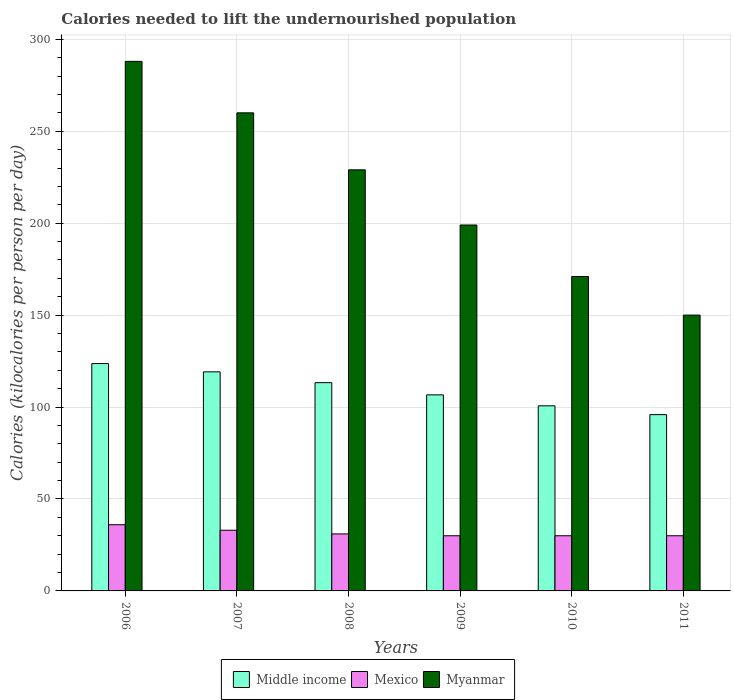How many groups of bars are there?
Keep it short and to the point. 6. Are the number of bars per tick equal to the number of legend labels?
Provide a short and direct response. Yes. Are the number of bars on each tick of the X-axis equal?
Your response must be concise. Yes. How many bars are there on the 6th tick from the left?
Provide a succinct answer. 3. How many bars are there on the 3rd tick from the right?
Your answer should be compact. 3. What is the label of the 5th group of bars from the left?
Give a very brief answer. 2010. In how many cases, is the number of bars for a given year not equal to the number of legend labels?
Keep it short and to the point. 0. What is the total calories needed to lift the undernourished population in Middle income in 2007?
Ensure brevity in your answer.  119.14. Across all years, what is the maximum total calories needed to lift the undernourished population in Middle income?
Your response must be concise. 123.65. Across all years, what is the minimum total calories needed to lift the undernourished population in Middle income?
Your answer should be very brief. 95.87. In which year was the total calories needed to lift the undernourished population in Middle income minimum?
Ensure brevity in your answer.  2011. What is the total total calories needed to lift the undernourished population in Mexico in the graph?
Ensure brevity in your answer.  190. What is the difference between the total calories needed to lift the undernourished population in Myanmar in 2007 and that in 2010?
Provide a succinct answer. 89. What is the difference between the total calories needed to lift the undernourished population in Middle income in 2010 and the total calories needed to lift the undernourished population in Mexico in 2009?
Make the answer very short. 70.68. What is the average total calories needed to lift the undernourished population in Myanmar per year?
Give a very brief answer. 216.17. In the year 2007, what is the difference between the total calories needed to lift the undernourished population in Myanmar and total calories needed to lift the undernourished population in Mexico?
Your response must be concise. 227. In how many years, is the total calories needed to lift the undernourished population in Myanmar greater than 130 kilocalories?
Provide a short and direct response. 6. What is the ratio of the total calories needed to lift the undernourished population in Mexico in 2008 to that in 2011?
Your response must be concise. 1.03. Is the total calories needed to lift the undernourished population in Mexico in 2006 less than that in 2010?
Provide a short and direct response. No. What is the difference between the highest and the second highest total calories needed to lift the undernourished population in Mexico?
Provide a short and direct response. 3. What is the difference between the highest and the lowest total calories needed to lift the undernourished population in Middle income?
Make the answer very short. 27.78. What does the 2nd bar from the right in 2011 represents?
Your answer should be compact. Mexico. How many years are there in the graph?
Give a very brief answer. 6. Are the values on the major ticks of Y-axis written in scientific E-notation?
Keep it short and to the point. No. Does the graph contain any zero values?
Keep it short and to the point. No. How are the legend labels stacked?
Keep it short and to the point. Horizontal. What is the title of the graph?
Ensure brevity in your answer.  Calories needed to lift the undernourished population. What is the label or title of the Y-axis?
Keep it short and to the point. Calories (kilocalories per person per day). What is the Calories (kilocalories per person per day) in Middle income in 2006?
Make the answer very short. 123.65. What is the Calories (kilocalories per person per day) in Mexico in 2006?
Make the answer very short. 36. What is the Calories (kilocalories per person per day) in Myanmar in 2006?
Offer a terse response. 288. What is the Calories (kilocalories per person per day) of Middle income in 2007?
Ensure brevity in your answer.  119.14. What is the Calories (kilocalories per person per day) in Myanmar in 2007?
Make the answer very short. 260. What is the Calories (kilocalories per person per day) of Middle income in 2008?
Offer a terse response. 113.26. What is the Calories (kilocalories per person per day) in Mexico in 2008?
Your answer should be compact. 31. What is the Calories (kilocalories per person per day) in Myanmar in 2008?
Ensure brevity in your answer.  229. What is the Calories (kilocalories per person per day) of Middle income in 2009?
Give a very brief answer. 106.62. What is the Calories (kilocalories per person per day) of Mexico in 2009?
Provide a succinct answer. 30. What is the Calories (kilocalories per person per day) in Myanmar in 2009?
Give a very brief answer. 199. What is the Calories (kilocalories per person per day) of Middle income in 2010?
Keep it short and to the point. 100.68. What is the Calories (kilocalories per person per day) of Myanmar in 2010?
Your answer should be compact. 171. What is the Calories (kilocalories per person per day) of Middle income in 2011?
Your answer should be very brief. 95.87. What is the Calories (kilocalories per person per day) of Mexico in 2011?
Your answer should be very brief. 30. What is the Calories (kilocalories per person per day) in Myanmar in 2011?
Your answer should be very brief. 150. Across all years, what is the maximum Calories (kilocalories per person per day) of Middle income?
Make the answer very short. 123.65. Across all years, what is the maximum Calories (kilocalories per person per day) of Mexico?
Ensure brevity in your answer.  36. Across all years, what is the maximum Calories (kilocalories per person per day) of Myanmar?
Ensure brevity in your answer.  288. Across all years, what is the minimum Calories (kilocalories per person per day) of Middle income?
Ensure brevity in your answer.  95.87. Across all years, what is the minimum Calories (kilocalories per person per day) of Myanmar?
Your response must be concise. 150. What is the total Calories (kilocalories per person per day) in Middle income in the graph?
Give a very brief answer. 659.21. What is the total Calories (kilocalories per person per day) in Mexico in the graph?
Offer a very short reply. 190. What is the total Calories (kilocalories per person per day) of Myanmar in the graph?
Offer a terse response. 1297. What is the difference between the Calories (kilocalories per person per day) of Middle income in 2006 and that in 2007?
Offer a very short reply. 4.51. What is the difference between the Calories (kilocalories per person per day) of Middle income in 2006 and that in 2008?
Give a very brief answer. 10.39. What is the difference between the Calories (kilocalories per person per day) in Middle income in 2006 and that in 2009?
Offer a very short reply. 17.03. What is the difference between the Calories (kilocalories per person per day) of Myanmar in 2006 and that in 2009?
Ensure brevity in your answer.  89. What is the difference between the Calories (kilocalories per person per day) of Middle income in 2006 and that in 2010?
Offer a very short reply. 22.97. What is the difference between the Calories (kilocalories per person per day) of Mexico in 2006 and that in 2010?
Offer a terse response. 6. What is the difference between the Calories (kilocalories per person per day) of Myanmar in 2006 and that in 2010?
Make the answer very short. 117. What is the difference between the Calories (kilocalories per person per day) of Middle income in 2006 and that in 2011?
Your response must be concise. 27.78. What is the difference between the Calories (kilocalories per person per day) in Myanmar in 2006 and that in 2011?
Offer a terse response. 138. What is the difference between the Calories (kilocalories per person per day) in Middle income in 2007 and that in 2008?
Provide a succinct answer. 5.88. What is the difference between the Calories (kilocalories per person per day) of Myanmar in 2007 and that in 2008?
Offer a terse response. 31. What is the difference between the Calories (kilocalories per person per day) of Middle income in 2007 and that in 2009?
Ensure brevity in your answer.  12.51. What is the difference between the Calories (kilocalories per person per day) in Mexico in 2007 and that in 2009?
Your response must be concise. 3. What is the difference between the Calories (kilocalories per person per day) of Middle income in 2007 and that in 2010?
Offer a very short reply. 18.46. What is the difference between the Calories (kilocalories per person per day) of Mexico in 2007 and that in 2010?
Offer a very short reply. 3. What is the difference between the Calories (kilocalories per person per day) in Myanmar in 2007 and that in 2010?
Give a very brief answer. 89. What is the difference between the Calories (kilocalories per person per day) of Middle income in 2007 and that in 2011?
Ensure brevity in your answer.  23.27. What is the difference between the Calories (kilocalories per person per day) of Myanmar in 2007 and that in 2011?
Give a very brief answer. 110. What is the difference between the Calories (kilocalories per person per day) in Middle income in 2008 and that in 2009?
Make the answer very short. 6.63. What is the difference between the Calories (kilocalories per person per day) in Mexico in 2008 and that in 2009?
Give a very brief answer. 1. What is the difference between the Calories (kilocalories per person per day) in Middle income in 2008 and that in 2010?
Offer a very short reply. 12.58. What is the difference between the Calories (kilocalories per person per day) in Mexico in 2008 and that in 2010?
Ensure brevity in your answer.  1. What is the difference between the Calories (kilocalories per person per day) of Middle income in 2008 and that in 2011?
Give a very brief answer. 17.39. What is the difference between the Calories (kilocalories per person per day) in Myanmar in 2008 and that in 2011?
Your response must be concise. 79. What is the difference between the Calories (kilocalories per person per day) of Middle income in 2009 and that in 2010?
Your response must be concise. 5.95. What is the difference between the Calories (kilocalories per person per day) of Mexico in 2009 and that in 2010?
Keep it short and to the point. 0. What is the difference between the Calories (kilocalories per person per day) in Myanmar in 2009 and that in 2010?
Provide a succinct answer. 28. What is the difference between the Calories (kilocalories per person per day) of Middle income in 2009 and that in 2011?
Offer a terse response. 10.76. What is the difference between the Calories (kilocalories per person per day) in Myanmar in 2009 and that in 2011?
Your answer should be very brief. 49. What is the difference between the Calories (kilocalories per person per day) of Middle income in 2010 and that in 2011?
Your response must be concise. 4.81. What is the difference between the Calories (kilocalories per person per day) of Middle income in 2006 and the Calories (kilocalories per person per day) of Mexico in 2007?
Provide a short and direct response. 90.65. What is the difference between the Calories (kilocalories per person per day) of Middle income in 2006 and the Calories (kilocalories per person per day) of Myanmar in 2007?
Your answer should be compact. -136.35. What is the difference between the Calories (kilocalories per person per day) in Mexico in 2006 and the Calories (kilocalories per person per day) in Myanmar in 2007?
Give a very brief answer. -224. What is the difference between the Calories (kilocalories per person per day) in Middle income in 2006 and the Calories (kilocalories per person per day) in Mexico in 2008?
Make the answer very short. 92.65. What is the difference between the Calories (kilocalories per person per day) of Middle income in 2006 and the Calories (kilocalories per person per day) of Myanmar in 2008?
Your response must be concise. -105.35. What is the difference between the Calories (kilocalories per person per day) in Mexico in 2006 and the Calories (kilocalories per person per day) in Myanmar in 2008?
Ensure brevity in your answer.  -193. What is the difference between the Calories (kilocalories per person per day) in Middle income in 2006 and the Calories (kilocalories per person per day) in Mexico in 2009?
Offer a terse response. 93.65. What is the difference between the Calories (kilocalories per person per day) in Middle income in 2006 and the Calories (kilocalories per person per day) in Myanmar in 2009?
Your answer should be compact. -75.35. What is the difference between the Calories (kilocalories per person per day) of Mexico in 2006 and the Calories (kilocalories per person per day) of Myanmar in 2009?
Ensure brevity in your answer.  -163. What is the difference between the Calories (kilocalories per person per day) in Middle income in 2006 and the Calories (kilocalories per person per day) in Mexico in 2010?
Offer a terse response. 93.65. What is the difference between the Calories (kilocalories per person per day) of Middle income in 2006 and the Calories (kilocalories per person per day) of Myanmar in 2010?
Your answer should be very brief. -47.35. What is the difference between the Calories (kilocalories per person per day) in Mexico in 2006 and the Calories (kilocalories per person per day) in Myanmar in 2010?
Provide a succinct answer. -135. What is the difference between the Calories (kilocalories per person per day) in Middle income in 2006 and the Calories (kilocalories per person per day) in Mexico in 2011?
Make the answer very short. 93.65. What is the difference between the Calories (kilocalories per person per day) of Middle income in 2006 and the Calories (kilocalories per person per day) of Myanmar in 2011?
Provide a short and direct response. -26.35. What is the difference between the Calories (kilocalories per person per day) of Mexico in 2006 and the Calories (kilocalories per person per day) of Myanmar in 2011?
Your answer should be very brief. -114. What is the difference between the Calories (kilocalories per person per day) of Middle income in 2007 and the Calories (kilocalories per person per day) of Mexico in 2008?
Keep it short and to the point. 88.14. What is the difference between the Calories (kilocalories per person per day) in Middle income in 2007 and the Calories (kilocalories per person per day) in Myanmar in 2008?
Your answer should be very brief. -109.86. What is the difference between the Calories (kilocalories per person per day) in Mexico in 2007 and the Calories (kilocalories per person per day) in Myanmar in 2008?
Your answer should be compact. -196. What is the difference between the Calories (kilocalories per person per day) in Middle income in 2007 and the Calories (kilocalories per person per day) in Mexico in 2009?
Provide a succinct answer. 89.14. What is the difference between the Calories (kilocalories per person per day) in Middle income in 2007 and the Calories (kilocalories per person per day) in Myanmar in 2009?
Offer a very short reply. -79.86. What is the difference between the Calories (kilocalories per person per day) of Mexico in 2007 and the Calories (kilocalories per person per day) of Myanmar in 2009?
Ensure brevity in your answer.  -166. What is the difference between the Calories (kilocalories per person per day) in Middle income in 2007 and the Calories (kilocalories per person per day) in Mexico in 2010?
Make the answer very short. 89.14. What is the difference between the Calories (kilocalories per person per day) of Middle income in 2007 and the Calories (kilocalories per person per day) of Myanmar in 2010?
Your response must be concise. -51.86. What is the difference between the Calories (kilocalories per person per day) in Mexico in 2007 and the Calories (kilocalories per person per day) in Myanmar in 2010?
Make the answer very short. -138. What is the difference between the Calories (kilocalories per person per day) in Middle income in 2007 and the Calories (kilocalories per person per day) in Mexico in 2011?
Offer a very short reply. 89.14. What is the difference between the Calories (kilocalories per person per day) in Middle income in 2007 and the Calories (kilocalories per person per day) in Myanmar in 2011?
Offer a terse response. -30.86. What is the difference between the Calories (kilocalories per person per day) in Mexico in 2007 and the Calories (kilocalories per person per day) in Myanmar in 2011?
Offer a very short reply. -117. What is the difference between the Calories (kilocalories per person per day) of Middle income in 2008 and the Calories (kilocalories per person per day) of Mexico in 2009?
Your response must be concise. 83.26. What is the difference between the Calories (kilocalories per person per day) of Middle income in 2008 and the Calories (kilocalories per person per day) of Myanmar in 2009?
Ensure brevity in your answer.  -85.74. What is the difference between the Calories (kilocalories per person per day) of Mexico in 2008 and the Calories (kilocalories per person per day) of Myanmar in 2009?
Offer a terse response. -168. What is the difference between the Calories (kilocalories per person per day) in Middle income in 2008 and the Calories (kilocalories per person per day) in Mexico in 2010?
Offer a very short reply. 83.26. What is the difference between the Calories (kilocalories per person per day) of Middle income in 2008 and the Calories (kilocalories per person per day) of Myanmar in 2010?
Your answer should be compact. -57.74. What is the difference between the Calories (kilocalories per person per day) of Mexico in 2008 and the Calories (kilocalories per person per day) of Myanmar in 2010?
Provide a short and direct response. -140. What is the difference between the Calories (kilocalories per person per day) of Middle income in 2008 and the Calories (kilocalories per person per day) of Mexico in 2011?
Give a very brief answer. 83.26. What is the difference between the Calories (kilocalories per person per day) of Middle income in 2008 and the Calories (kilocalories per person per day) of Myanmar in 2011?
Ensure brevity in your answer.  -36.74. What is the difference between the Calories (kilocalories per person per day) in Mexico in 2008 and the Calories (kilocalories per person per day) in Myanmar in 2011?
Offer a terse response. -119. What is the difference between the Calories (kilocalories per person per day) of Middle income in 2009 and the Calories (kilocalories per person per day) of Mexico in 2010?
Offer a terse response. 76.62. What is the difference between the Calories (kilocalories per person per day) in Middle income in 2009 and the Calories (kilocalories per person per day) in Myanmar in 2010?
Your answer should be very brief. -64.38. What is the difference between the Calories (kilocalories per person per day) of Mexico in 2009 and the Calories (kilocalories per person per day) of Myanmar in 2010?
Provide a succinct answer. -141. What is the difference between the Calories (kilocalories per person per day) in Middle income in 2009 and the Calories (kilocalories per person per day) in Mexico in 2011?
Your response must be concise. 76.62. What is the difference between the Calories (kilocalories per person per day) of Middle income in 2009 and the Calories (kilocalories per person per day) of Myanmar in 2011?
Make the answer very short. -43.38. What is the difference between the Calories (kilocalories per person per day) in Mexico in 2009 and the Calories (kilocalories per person per day) in Myanmar in 2011?
Keep it short and to the point. -120. What is the difference between the Calories (kilocalories per person per day) of Middle income in 2010 and the Calories (kilocalories per person per day) of Mexico in 2011?
Make the answer very short. 70.68. What is the difference between the Calories (kilocalories per person per day) in Middle income in 2010 and the Calories (kilocalories per person per day) in Myanmar in 2011?
Keep it short and to the point. -49.32. What is the difference between the Calories (kilocalories per person per day) of Mexico in 2010 and the Calories (kilocalories per person per day) of Myanmar in 2011?
Offer a terse response. -120. What is the average Calories (kilocalories per person per day) of Middle income per year?
Ensure brevity in your answer.  109.87. What is the average Calories (kilocalories per person per day) of Mexico per year?
Your answer should be very brief. 31.67. What is the average Calories (kilocalories per person per day) of Myanmar per year?
Your answer should be very brief. 216.17. In the year 2006, what is the difference between the Calories (kilocalories per person per day) of Middle income and Calories (kilocalories per person per day) of Mexico?
Offer a terse response. 87.65. In the year 2006, what is the difference between the Calories (kilocalories per person per day) in Middle income and Calories (kilocalories per person per day) in Myanmar?
Your answer should be very brief. -164.35. In the year 2006, what is the difference between the Calories (kilocalories per person per day) of Mexico and Calories (kilocalories per person per day) of Myanmar?
Your answer should be compact. -252. In the year 2007, what is the difference between the Calories (kilocalories per person per day) of Middle income and Calories (kilocalories per person per day) of Mexico?
Give a very brief answer. 86.14. In the year 2007, what is the difference between the Calories (kilocalories per person per day) in Middle income and Calories (kilocalories per person per day) in Myanmar?
Provide a short and direct response. -140.86. In the year 2007, what is the difference between the Calories (kilocalories per person per day) of Mexico and Calories (kilocalories per person per day) of Myanmar?
Your answer should be very brief. -227. In the year 2008, what is the difference between the Calories (kilocalories per person per day) in Middle income and Calories (kilocalories per person per day) in Mexico?
Provide a succinct answer. 82.26. In the year 2008, what is the difference between the Calories (kilocalories per person per day) of Middle income and Calories (kilocalories per person per day) of Myanmar?
Your answer should be compact. -115.74. In the year 2008, what is the difference between the Calories (kilocalories per person per day) in Mexico and Calories (kilocalories per person per day) in Myanmar?
Make the answer very short. -198. In the year 2009, what is the difference between the Calories (kilocalories per person per day) of Middle income and Calories (kilocalories per person per day) of Mexico?
Make the answer very short. 76.62. In the year 2009, what is the difference between the Calories (kilocalories per person per day) of Middle income and Calories (kilocalories per person per day) of Myanmar?
Provide a succinct answer. -92.38. In the year 2009, what is the difference between the Calories (kilocalories per person per day) of Mexico and Calories (kilocalories per person per day) of Myanmar?
Provide a short and direct response. -169. In the year 2010, what is the difference between the Calories (kilocalories per person per day) in Middle income and Calories (kilocalories per person per day) in Mexico?
Offer a very short reply. 70.68. In the year 2010, what is the difference between the Calories (kilocalories per person per day) in Middle income and Calories (kilocalories per person per day) in Myanmar?
Offer a very short reply. -70.32. In the year 2010, what is the difference between the Calories (kilocalories per person per day) of Mexico and Calories (kilocalories per person per day) of Myanmar?
Provide a short and direct response. -141. In the year 2011, what is the difference between the Calories (kilocalories per person per day) in Middle income and Calories (kilocalories per person per day) in Mexico?
Offer a terse response. 65.87. In the year 2011, what is the difference between the Calories (kilocalories per person per day) of Middle income and Calories (kilocalories per person per day) of Myanmar?
Offer a very short reply. -54.13. In the year 2011, what is the difference between the Calories (kilocalories per person per day) in Mexico and Calories (kilocalories per person per day) in Myanmar?
Keep it short and to the point. -120. What is the ratio of the Calories (kilocalories per person per day) of Middle income in 2006 to that in 2007?
Make the answer very short. 1.04. What is the ratio of the Calories (kilocalories per person per day) in Myanmar in 2006 to that in 2007?
Your answer should be very brief. 1.11. What is the ratio of the Calories (kilocalories per person per day) in Middle income in 2006 to that in 2008?
Make the answer very short. 1.09. What is the ratio of the Calories (kilocalories per person per day) in Mexico in 2006 to that in 2008?
Ensure brevity in your answer.  1.16. What is the ratio of the Calories (kilocalories per person per day) of Myanmar in 2006 to that in 2008?
Ensure brevity in your answer.  1.26. What is the ratio of the Calories (kilocalories per person per day) of Middle income in 2006 to that in 2009?
Offer a terse response. 1.16. What is the ratio of the Calories (kilocalories per person per day) of Myanmar in 2006 to that in 2009?
Ensure brevity in your answer.  1.45. What is the ratio of the Calories (kilocalories per person per day) in Middle income in 2006 to that in 2010?
Keep it short and to the point. 1.23. What is the ratio of the Calories (kilocalories per person per day) of Mexico in 2006 to that in 2010?
Offer a terse response. 1.2. What is the ratio of the Calories (kilocalories per person per day) of Myanmar in 2006 to that in 2010?
Your response must be concise. 1.68. What is the ratio of the Calories (kilocalories per person per day) of Middle income in 2006 to that in 2011?
Provide a short and direct response. 1.29. What is the ratio of the Calories (kilocalories per person per day) in Mexico in 2006 to that in 2011?
Make the answer very short. 1.2. What is the ratio of the Calories (kilocalories per person per day) of Myanmar in 2006 to that in 2011?
Your answer should be compact. 1.92. What is the ratio of the Calories (kilocalories per person per day) of Middle income in 2007 to that in 2008?
Keep it short and to the point. 1.05. What is the ratio of the Calories (kilocalories per person per day) in Mexico in 2007 to that in 2008?
Your response must be concise. 1.06. What is the ratio of the Calories (kilocalories per person per day) in Myanmar in 2007 to that in 2008?
Keep it short and to the point. 1.14. What is the ratio of the Calories (kilocalories per person per day) of Middle income in 2007 to that in 2009?
Your response must be concise. 1.12. What is the ratio of the Calories (kilocalories per person per day) in Mexico in 2007 to that in 2009?
Offer a very short reply. 1.1. What is the ratio of the Calories (kilocalories per person per day) in Myanmar in 2007 to that in 2009?
Ensure brevity in your answer.  1.31. What is the ratio of the Calories (kilocalories per person per day) of Middle income in 2007 to that in 2010?
Ensure brevity in your answer.  1.18. What is the ratio of the Calories (kilocalories per person per day) of Mexico in 2007 to that in 2010?
Provide a short and direct response. 1.1. What is the ratio of the Calories (kilocalories per person per day) of Myanmar in 2007 to that in 2010?
Your answer should be compact. 1.52. What is the ratio of the Calories (kilocalories per person per day) of Middle income in 2007 to that in 2011?
Your response must be concise. 1.24. What is the ratio of the Calories (kilocalories per person per day) of Myanmar in 2007 to that in 2011?
Provide a short and direct response. 1.73. What is the ratio of the Calories (kilocalories per person per day) of Middle income in 2008 to that in 2009?
Offer a very short reply. 1.06. What is the ratio of the Calories (kilocalories per person per day) of Mexico in 2008 to that in 2009?
Give a very brief answer. 1.03. What is the ratio of the Calories (kilocalories per person per day) in Myanmar in 2008 to that in 2009?
Your answer should be compact. 1.15. What is the ratio of the Calories (kilocalories per person per day) of Middle income in 2008 to that in 2010?
Offer a terse response. 1.12. What is the ratio of the Calories (kilocalories per person per day) of Mexico in 2008 to that in 2010?
Offer a very short reply. 1.03. What is the ratio of the Calories (kilocalories per person per day) in Myanmar in 2008 to that in 2010?
Your answer should be very brief. 1.34. What is the ratio of the Calories (kilocalories per person per day) of Middle income in 2008 to that in 2011?
Provide a short and direct response. 1.18. What is the ratio of the Calories (kilocalories per person per day) in Mexico in 2008 to that in 2011?
Offer a terse response. 1.03. What is the ratio of the Calories (kilocalories per person per day) of Myanmar in 2008 to that in 2011?
Your response must be concise. 1.53. What is the ratio of the Calories (kilocalories per person per day) of Middle income in 2009 to that in 2010?
Ensure brevity in your answer.  1.06. What is the ratio of the Calories (kilocalories per person per day) of Mexico in 2009 to that in 2010?
Make the answer very short. 1. What is the ratio of the Calories (kilocalories per person per day) of Myanmar in 2009 to that in 2010?
Your response must be concise. 1.16. What is the ratio of the Calories (kilocalories per person per day) of Middle income in 2009 to that in 2011?
Provide a short and direct response. 1.11. What is the ratio of the Calories (kilocalories per person per day) in Mexico in 2009 to that in 2011?
Your answer should be very brief. 1. What is the ratio of the Calories (kilocalories per person per day) of Myanmar in 2009 to that in 2011?
Give a very brief answer. 1.33. What is the ratio of the Calories (kilocalories per person per day) in Middle income in 2010 to that in 2011?
Your response must be concise. 1.05. What is the ratio of the Calories (kilocalories per person per day) of Myanmar in 2010 to that in 2011?
Provide a succinct answer. 1.14. What is the difference between the highest and the second highest Calories (kilocalories per person per day) in Middle income?
Offer a terse response. 4.51. What is the difference between the highest and the second highest Calories (kilocalories per person per day) in Mexico?
Your response must be concise. 3. What is the difference between the highest and the lowest Calories (kilocalories per person per day) in Middle income?
Give a very brief answer. 27.78. What is the difference between the highest and the lowest Calories (kilocalories per person per day) in Myanmar?
Keep it short and to the point. 138. 